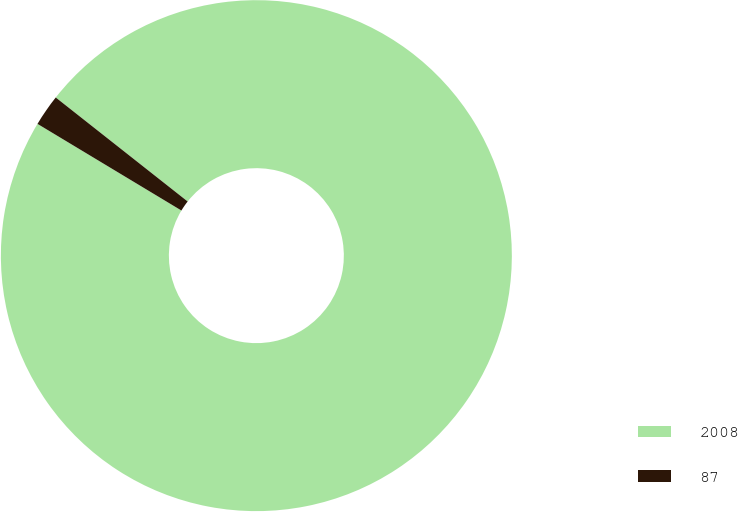Convert chart. <chart><loc_0><loc_0><loc_500><loc_500><pie_chart><fcel>2008<fcel>87<nl><fcel>98.0%<fcel>2.0%<nl></chart> 